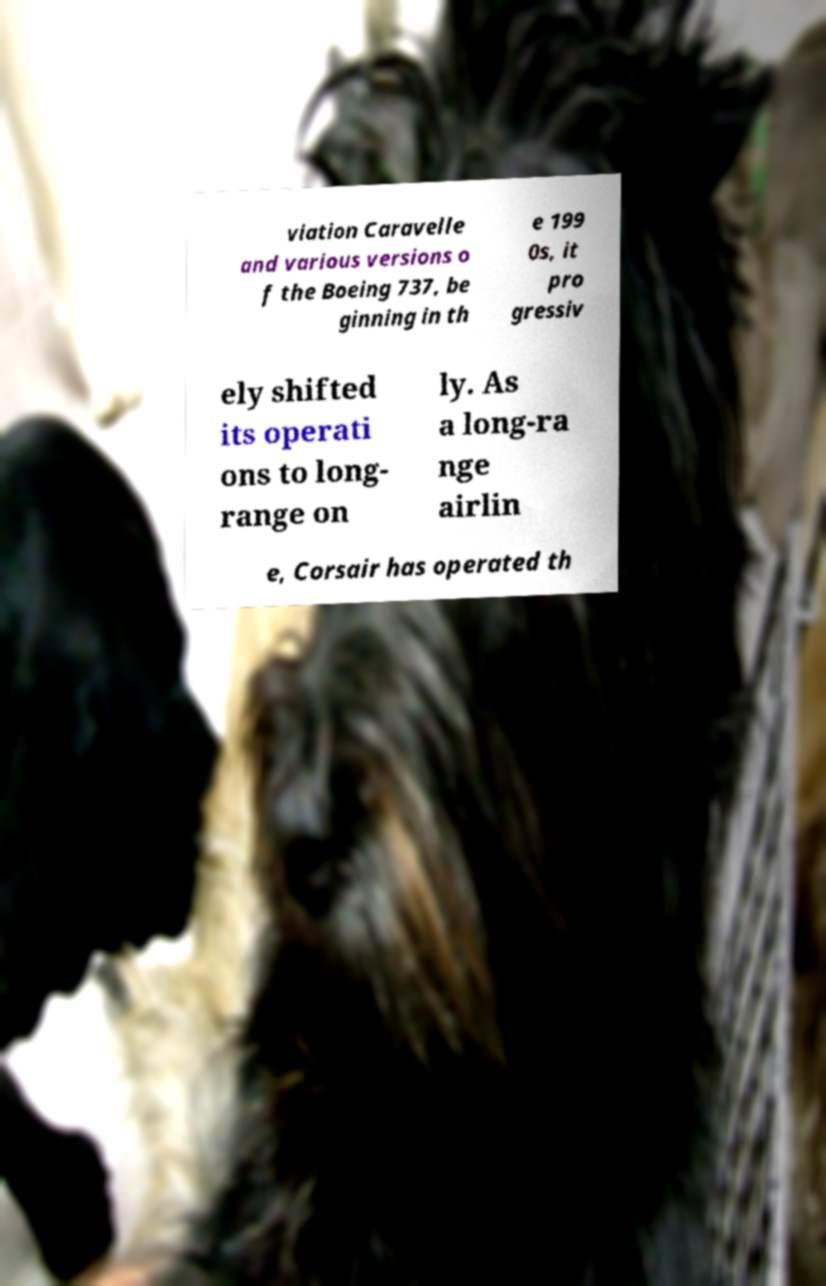Could you extract and type out the text from this image? viation Caravelle and various versions o f the Boeing 737, be ginning in th e 199 0s, it pro gressiv ely shifted its operati ons to long- range on ly. As a long-ra nge airlin e, Corsair has operated th 